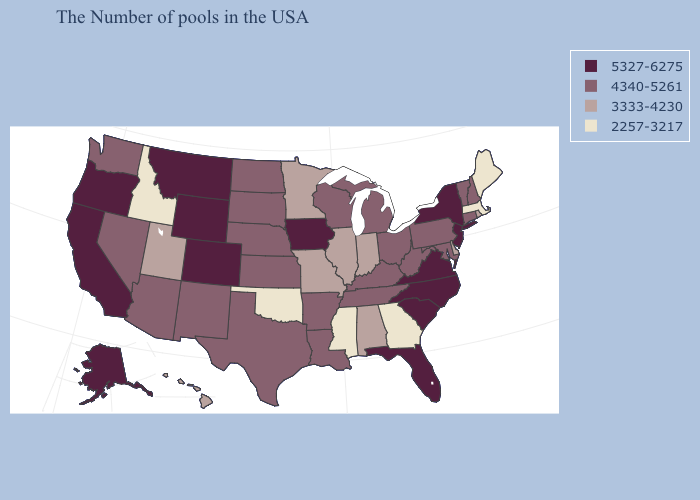What is the value of Oregon?
Give a very brief answer. 5327-6275. What is the value of Indiana?
Quick response, please. 3333-4230. Which states have the highest value in the USA?
Concise answer only. New York, New Jersey, Virginia, North Carolina, South Carolina, Florida, Iowa, Wyoming, Colorado, Montana, California, Oregon, Alaska. Does Virginia have the highest value in the USA?
Answer briefly. Yes. Does Massachusetts have the same value as Montana?
Quick response, please. No. Name the states that have a value in the range 3333-4230?
Keep it brief. Rhode Island, Delaware, Indiana, Alabama, Illinois, Missouri, Minnesota, Utah, Hawaii. Name the states that have a value in the range 2257-3217?
Keep it brief. Maine, Massachusetts, Georgia, Mississippi, Oklahoma, Idaho. Among the states that border Illinois , which have the lowest value?
Keep it brief. Indiana, Missouri. Does Idaho have a higher value than Michigan?
Give a very brief answer. No. What is the highest value in states that border Mississippi?
Answer briefly. 4340-5261. What is the lowest value in the USA?
Short answer required. 2257-3217. Which states have the highest value in the USA?
Keep it brief. New York, New Jersey, Virginia, North Carolina, South Carolina, Florida, Iowa, Wyoming, Colorado, Montana, California, Oregon, Alaska. Name the states that have a value in the range 4340-5261?
Write a very short answer. New Hampshire, Vermont, Connecticut, Maryland, Pennsylvania, West Virginia, Ohio, Michigan, Kentucky, Tennessee, Wisconsin, Louisiana, Arkansas, Kansas, Nebraska, Texas, South Dakota, North Dakota, New Mexico, Arizona, Nevada, Washington. Does Oklahoma have the lowest value in the USA?
Answer briefly. Yes. What is the lowest value in the USA?
Answer briefly. 2257-3217. 